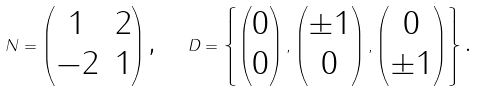<formula> <loc_0><loc_0><loc_500><loc_500>N = \begin{pmatrix} 1 & 2 \\ - 2 & 1 \end{pmatrix} \text {,\quad } D = \left \{ \begin{pmatrix} 0 \\ 0 \end{pmatrix} , \begin{pmatrix} \pm 1 \\ 0 \end{pmatrix} , \begin{pmatrix} 0 \\ \pm 1 \end{pmatrix} \right \} \text {.}</formula> 